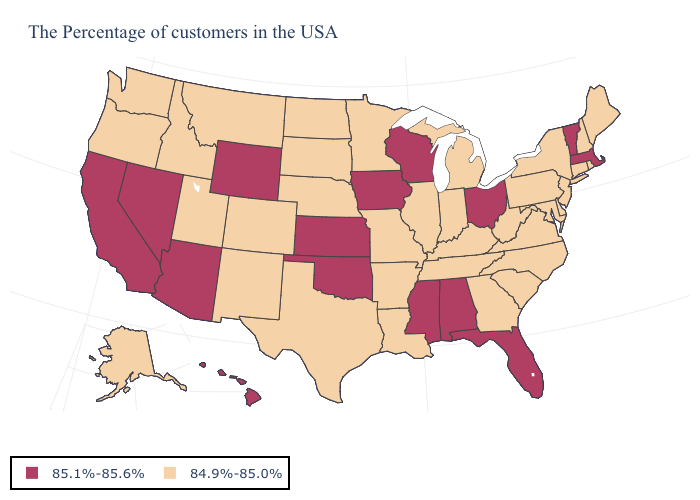What is the value of Maryland?
Give a very brief answer. 84.9%-85.0%. How many symbols are there in the legend?
Give a very brief answer. 2. Name the states that have a value in the range 84.9%-85.0%?
Be succinct. Maine, Rhode Island, New Hampshire, Connecticut, New York, New Jersey, Delaware, Maryland, Pennsylvania, Virginia, North Carolina, South Carolina, West Virginia, Georgia, Michigan, Kentucky, Indiana, Tennessee, Illinois, Louisiana, Missouri, Arkansas, Minnesota, Nebraska, Texas, South Dakota, North Dakota, Colorado, New Mexico, Utah, Montana, Idaho, Washington, Oregon, Alaska. Which states have the lowest value in the MidWest?
Quick response, please. Michigan, Indiana, Illinois, Missouri, Minnesota, Nebraska, South Dakota, North Dakota. Among the states that border Ohio , which have the lowest value?
Be succinct. Pennsylvania, West Virginia, Michigan, Kentucky, Indiana. Which states hav the highest value in the MidWest?
Give a very brief answer. Ohio, Wisconsin, Iowa, Kansas. Name the states that have a value in the range 85.1%-85.6%?
Short answer required. Massachusetts, Vermont, Ohio, Florida, Alabama, Wisconsin, Mississippi, Iowa, Kansas, Oklahoma, Wyoming, Arizona, Nevada, California, Hawaii. Which states hav the highest value in the West?
Be succinct. Wyoming, Arizona, Nevada, California, Hawaii. Does the map have missing data?
Give a very brief answer. No. Among the states that border South Dakota , which have the lowest value?
Concise answer only. Minnesota, Nebraska, North Dakota, Montana. What is the highest value in the Northeast ?
Quick response, please. 85.1%-85.6%. Does Massachusetts have the lowest value in the Northeast?
Answer briefly. No. Name the states that have a value in the range 85.1%-85.6%?
Be succinct. Massachusetts, Vermont, Ohio, Florida, Alabama, Wisconsin, Mississippi, Iowa, Kansas, Oklahoma, Wyoming, Arizona, Nevada, California, Hawaii. Which states have the lowest value in the Northeast?
Answer briefly. Maine, Rhode Island, New Hampshire, Connecticut, New York, New Jersey, Pennsylvania. 